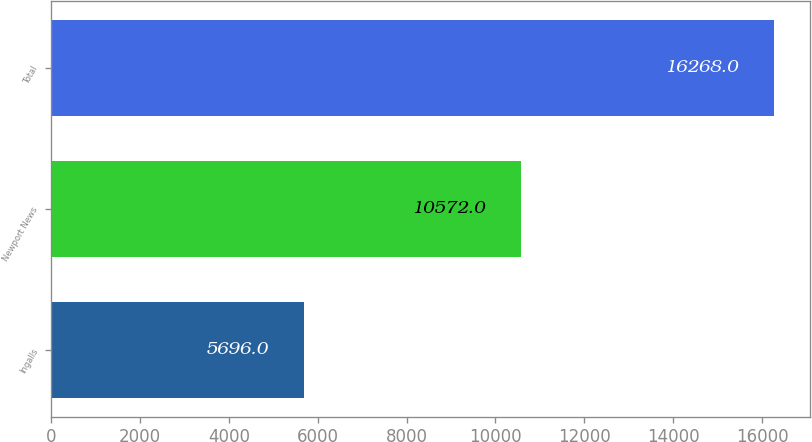<chart> <loc_0><loc_0><loc_500><loc_500><bar_chart><fcel>Ingalls<fcel>Newport News<fcel>Total<nl><fcel>5696<fcel>10572<fcel>16268<nl></chart> 